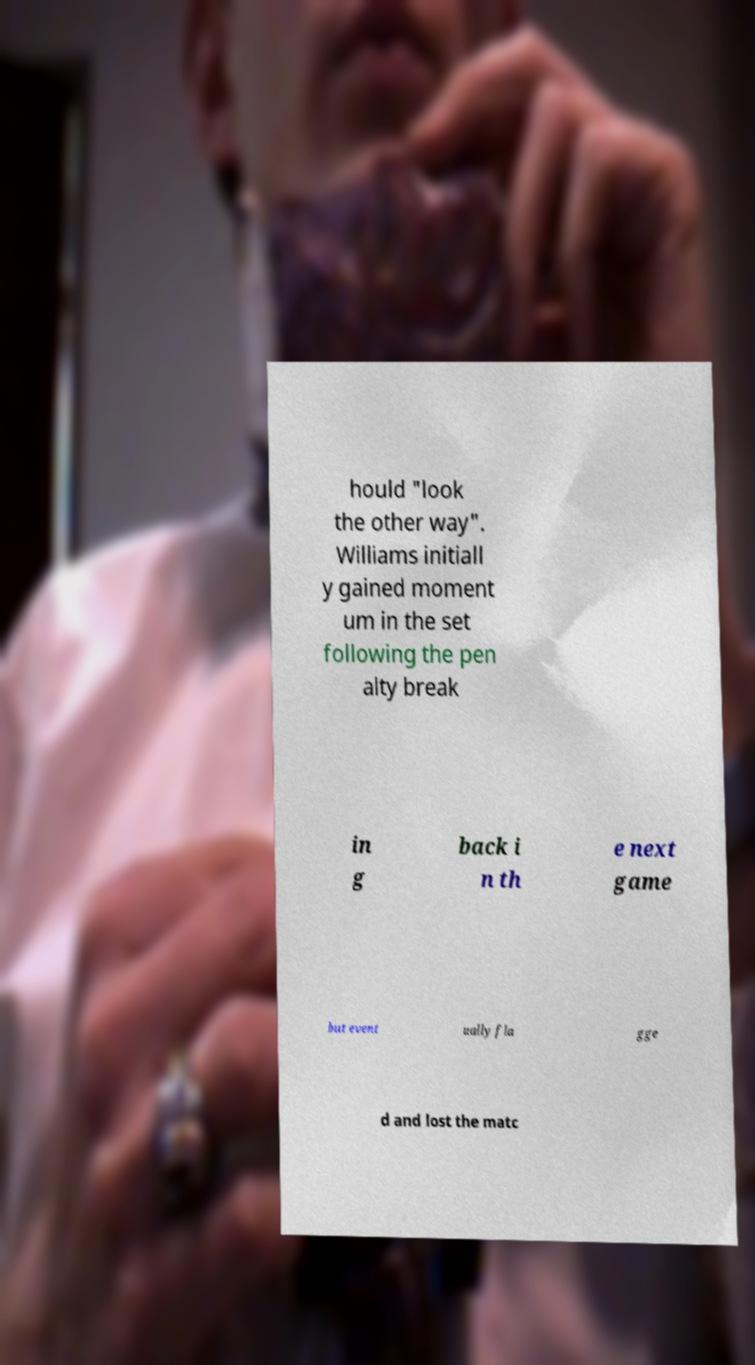There's text embedded in this image that I need extracted. Can you transcribe it verbatim? hould "look the other way". Williams initiall y gained moment um in the set following the pen alty break in g back i n th e next game but event ually fla gge d and lost the matc 